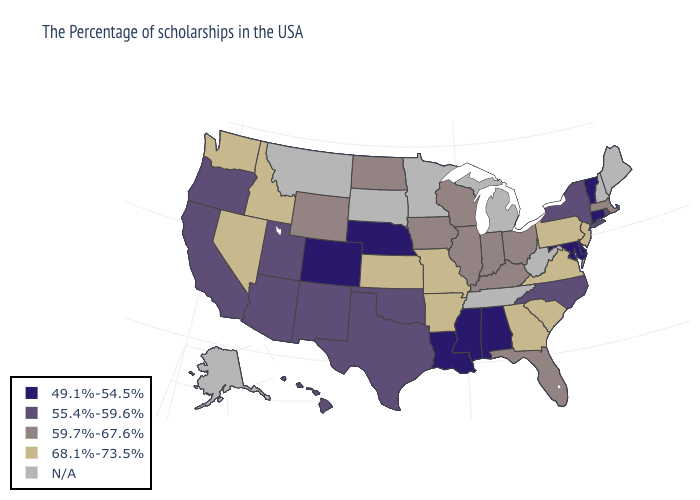What is the highest value in the Northeast ?
Be succinct. 68.1%-73.5%. What is the value of Alaska?
Give a very brief answer. N/A. Name the states that have a value in the range 49.1%-54.5%?
Short answer required. Vermont, Connecticut, Delaware, Maryland, Alabama, Mississippi, Louisiana, Nebraska, Colorado. Name the states that have a value in the range 68.1%-73.5%?
Quick response, please. New Jersey, Pennsylvania, Virginia, South Carolina, Georgia, Missouri, Arkansas, Kansas, Idaho, Nevada, Washington. Which states have the lowest value in the USA?
Be succinct. Vermont, Connecticut, Delaware, Maryland, Alabama, Mississippi, Louisiana, Nebraska, Colorado. Which states have the lowest value in the Northeast?
Write a very short answer. Vermont, Connecticut. Does South Carolina have the highest value in the USA?
Write a very short answer. Yes. What is the value of California?
Short answer required. 55.4%-59.6%. Among the states that border Georgia , which have the highest value?
Give a very brief answer. South Carolina. What is the value of Oklahoma?
Give a very brief answer. 55.4%-59.6%. Name the states that have a value in the range 55.4%-59.6%?
Quick response, please. Rhode Island, New York, North Carolina, Oklahoma, Texas, New Mexico, Utah, Arizona, California, Oregon, Hawaii. Among the states that border Tennessee , does Missouri have the highest value?
Short answer required. Yes. How many symbols are there in the legend?
Keep it brief. 5. Which states have the lowest value in the USA?
Give a very brief answer. Vermont, Connecticut, Delaware, Maryland, Alabama, Mississippi, Louisiana, Nebraska, Colorado. 